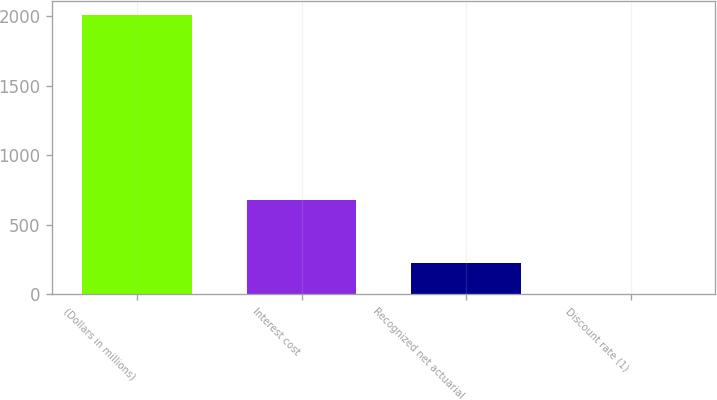Convert chart. <chart><loc_0><loc_0><loc_500><loc_500><bar_chart><fcel>(Dollars in millions)<fcel>Interest cost<fcel>Recognized net actuarial<fcel>Discount rate (1)<nl><fcel>2006<fcel>676<fcel>229<fcel>5.5<nl></chart> 